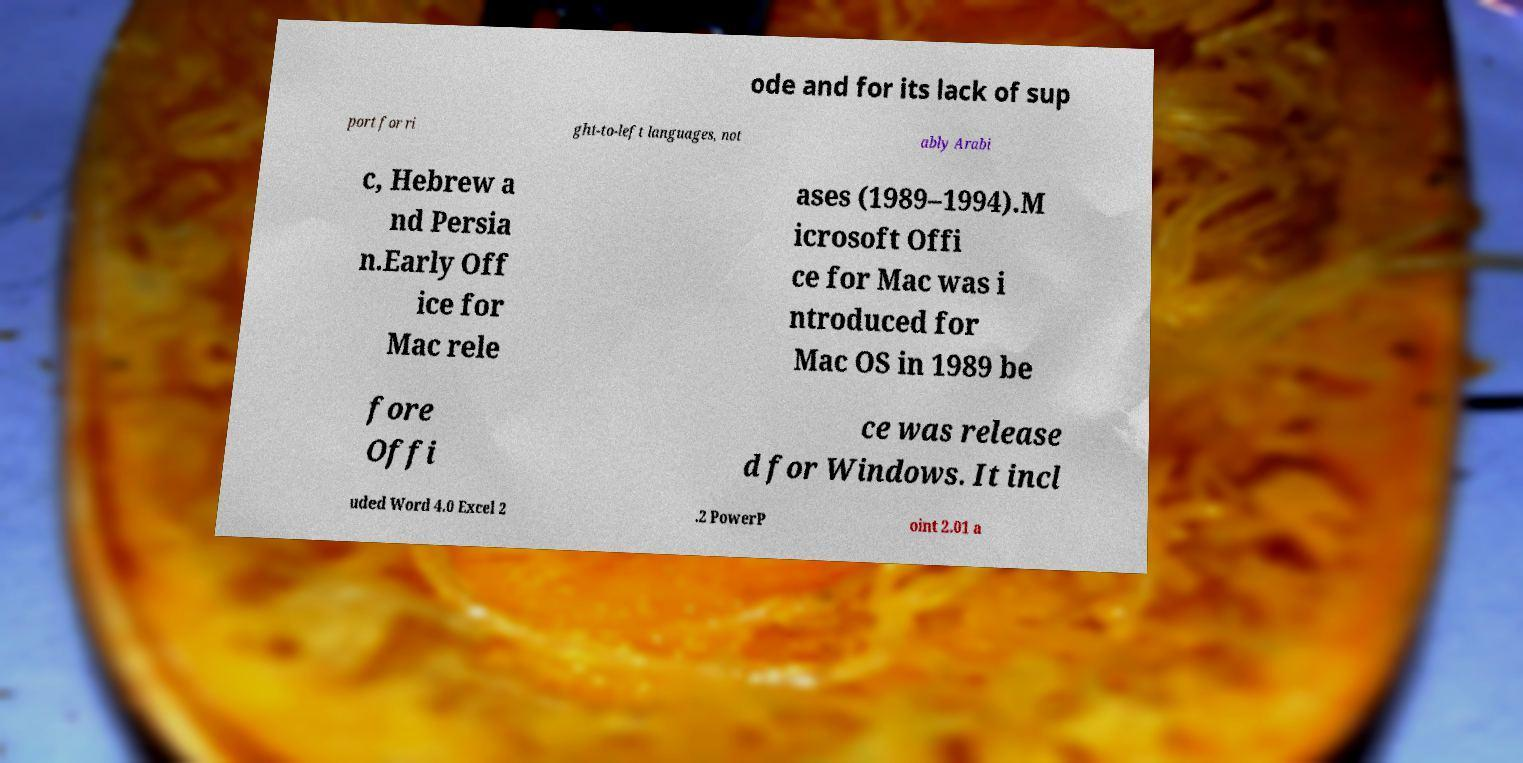What messages or text are displayed in this image? I need them in a readable, typed format. ode and for its lack of sup port for ri ght-to-left languages, not ably Arabi c, Hebrew a nd Persia n.Early Off ice for Mac rele ases (1989–1994).M icrosoft Offi ce for Mac was i ntroduced for Mac OS in 1989 be fore Offi ce was release d for Windows. It incl uded Word 4.0 Excel 2 .2 PowerP oint 2.01 a 